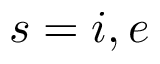Convert formula to latex. <formula><loc_0><loc_0><loc_500><loc_500>s = i , e</formula> 